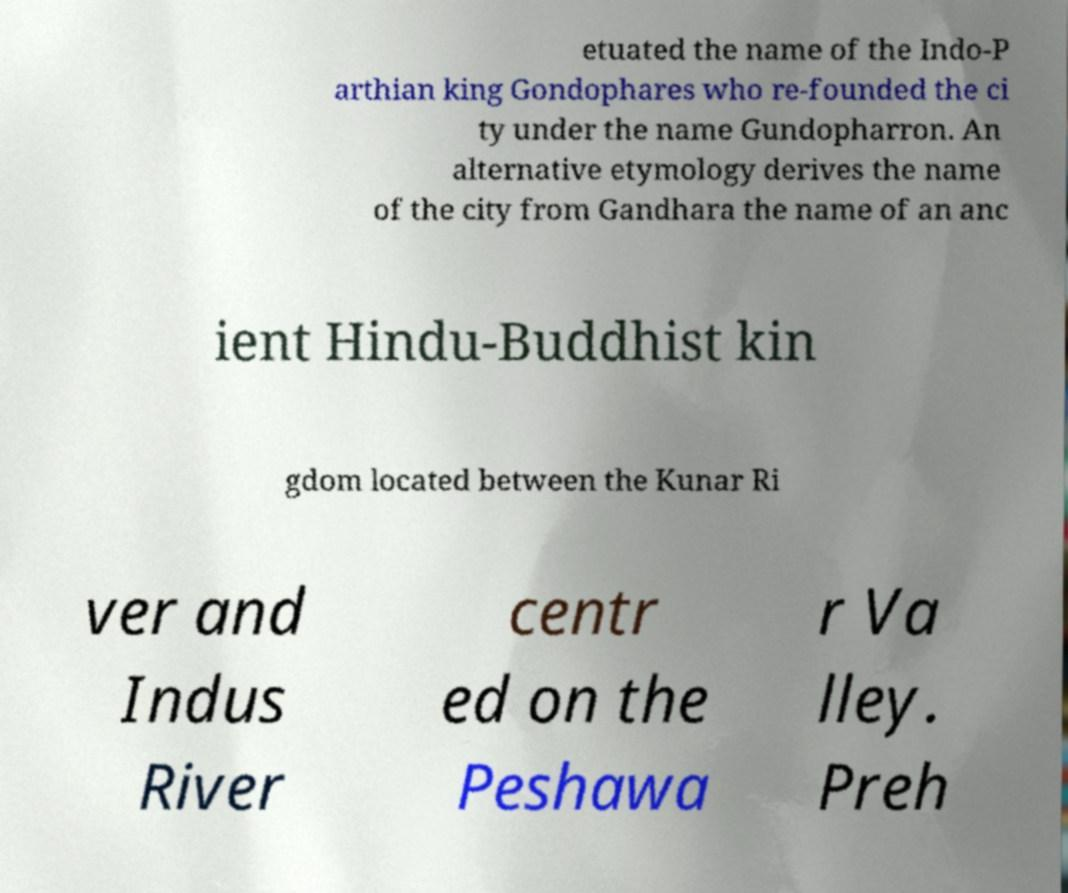Could you assist in decoding the text presented in this image and type it out clearly? etuated the name of the Indo-P arthian king Gondophares who re-founded the ci ty under the name Gundopharron. An alternative etymology derives the name of the city from Gandhara the name of an anc ient Hindu-Buddhist kin gdom located between the Kunar Ri ver and Indus River centr ed on the Peshawa r Va lley. Preh 